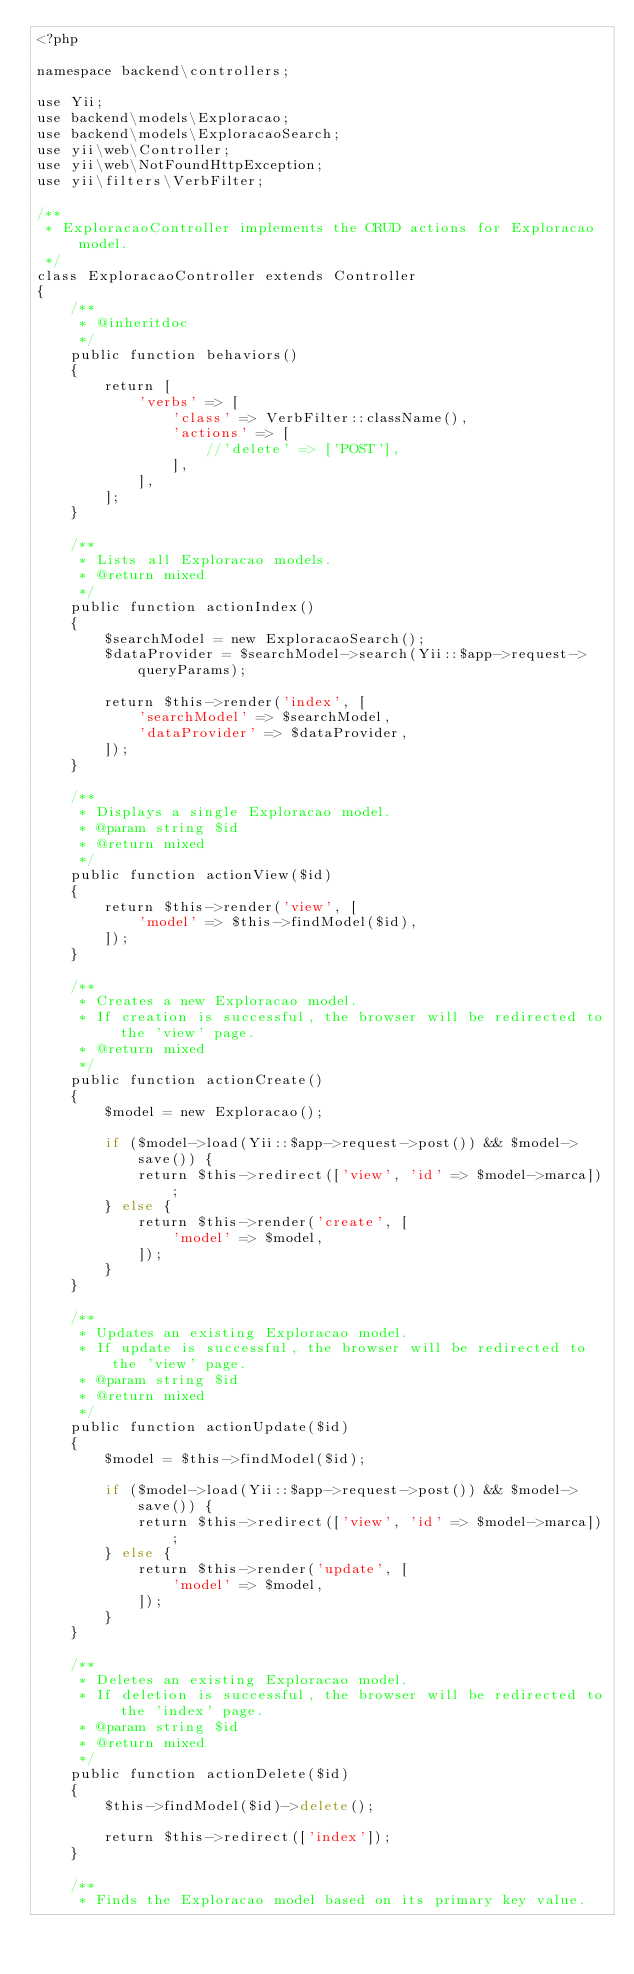<code> <loc_0><loc_0><loc_500><loc_500><_PHP_><?php

namespace backend\controllers;

use Yii;
use backend\models\Exploracao;
use backend\models\ExploracaoSearch;
use yii\web\Controller;
use yii\web\NotFoundHttpException;
use yii\filters\VerbFilter;

/**
 * ExploracaoController implements the CRUD actions for Exploracao model.
 */
class ExploracaoController extends Controller
{
    /**
     * @inheritdoc
     */
    public function behaviors()
    {
        return [
            'verbs' => [
                'class' => VerbFilter::className(),
                'actions' => [
                    //'delete' => ['POST'],
                ],
            ],
        ];
    }

    /**
     * Lists all Exploracao models.
     * @return mixed
     */
    public function actionIndex()
    {
        $searchModel = new ExploracaoSearch();
        $dataProvider = $searchModel->search(Yii::$app->request->queryParams);

        return $this->render('index', [
            'searchModel' => $searchModel,
            'dataProvider' => $dataProvider,
        ]);
    }

    /**
     * Displays a single Exploracao model.
     * @param string $id
     * @return mixed
     */
    public function actionView($id)
    {
        return $this->render('view', [
            'model' => $this->findModel($id),
        ]);
    }

    /**
     * Creates a new Exploracao model.
     * If creation is successful, the browser will be redirected to the 'view' page.
     * @return mixed
     */
    public function actionCreate()
    {
        $model = new Exploracao();

        if ($model->load(Yii::$app->request->post()) && $model->save()) {
            return $this->redirect(['view', 'id' => $model->marca]);
        } else {
            return $this->render('create', [
                'model' => $model,
            ]);
        }
    }

    /**
     * Updates an existing Exploracao model.
     * If update is successful, the browser will be redirected to the 'view' page.
     * @param string $id
     * @return mixed
     */
    public function actionUpdate($id)
    {
        $model = $this->findModel($id);

        if ($model->load(Yii::$app->request->post()) && $model->save()) {
            return $this->redirect(['view', 'id' => $model->marca]);
        } else {
            return $this->render('update', [
                'model' => $model,
            ]);
        }
    }

    /**
     * Deletes an existing Exploracao model.
     * If deletion is successful, the browser will be redirected to the 'index' page.
     * @param string $id
     * @return mixed
     */
    public function actionDelete($id)
    {
        $this->findModel($id)->delete();

        return $this->redirect(['index']);
    }

    /**
     * Finds the Exploracao model based on its primary key value.</code> 